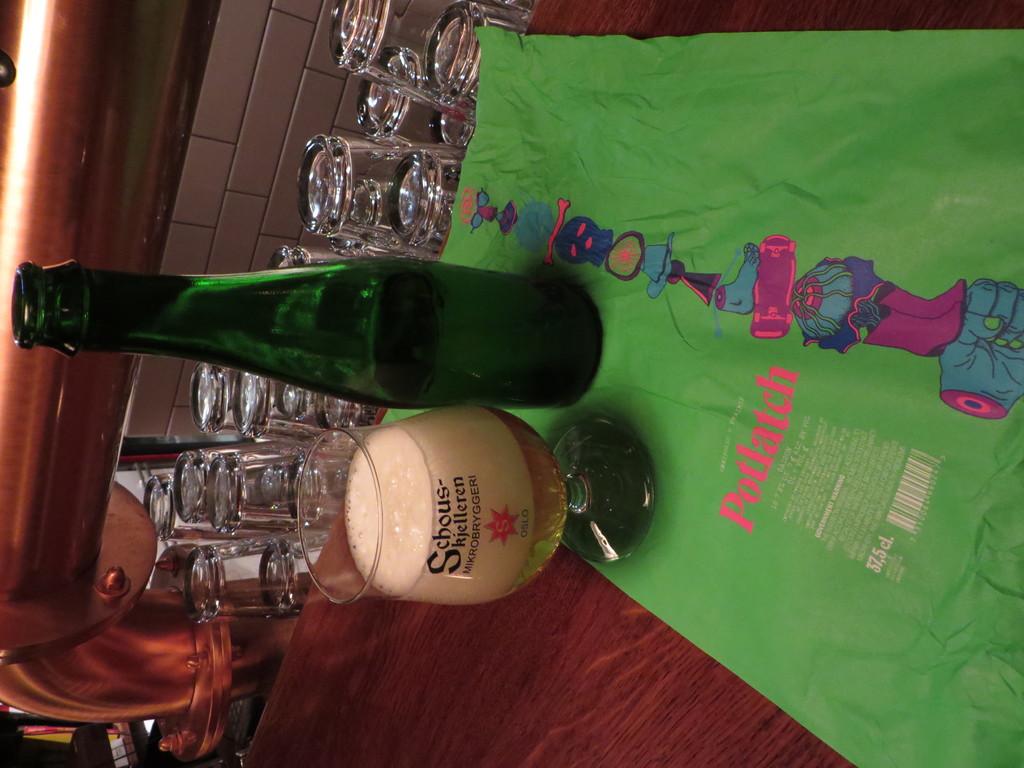What word is in pink on the green cloth?
Provide a succinct answer. Potlatch. 